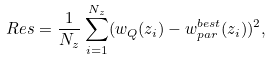<formula> <loc_0><loc_0><loc_500><loc_500>R e s = \frac { 1 } { N _ { z } } \sum _ { i = 1 } ^ { N _ { z } } ( w _ { Q } ( z _ { i } ) - w _ { p a r } ^ { b e s t } ( z _ { i } ) ) ^ { 2 } ,</formula> 